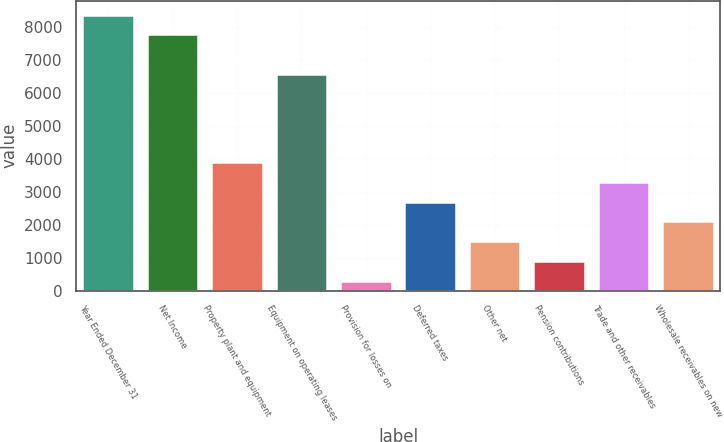Convert chart. <chart><loc_0><loc_0><loc_500><loc_500><bar_chart><fcel>Year Ended December 31<fcel>Net Income<fcel>Property plant and equipment<fcel>Equipment on operating leases<fcel>Provision for losses on<fcel>Deferred taxes<fcel>Other net<fcel>Pension contributions<fcel>Trade and other receivables<fcel>Wholesale receivables on new<nl><fcel>8368.14<fcel>7770.88<fcel>3888.69<fcel>6576.36<fcel>305.13<fcel>2694.17<fcel>1499.65<fcel>902.39<fcel>3291.43<fcel>2096.91<nl></chart> 